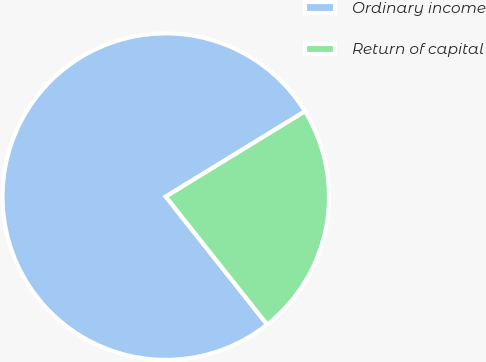Convert chart. <chart><loc_0><loc_0><loc_500><loc_500><pie_chart><fcel>Ordinary income<fcel>Return of capital<nl><fcel>76.92%<fcel>23.08%<nl></chart> 